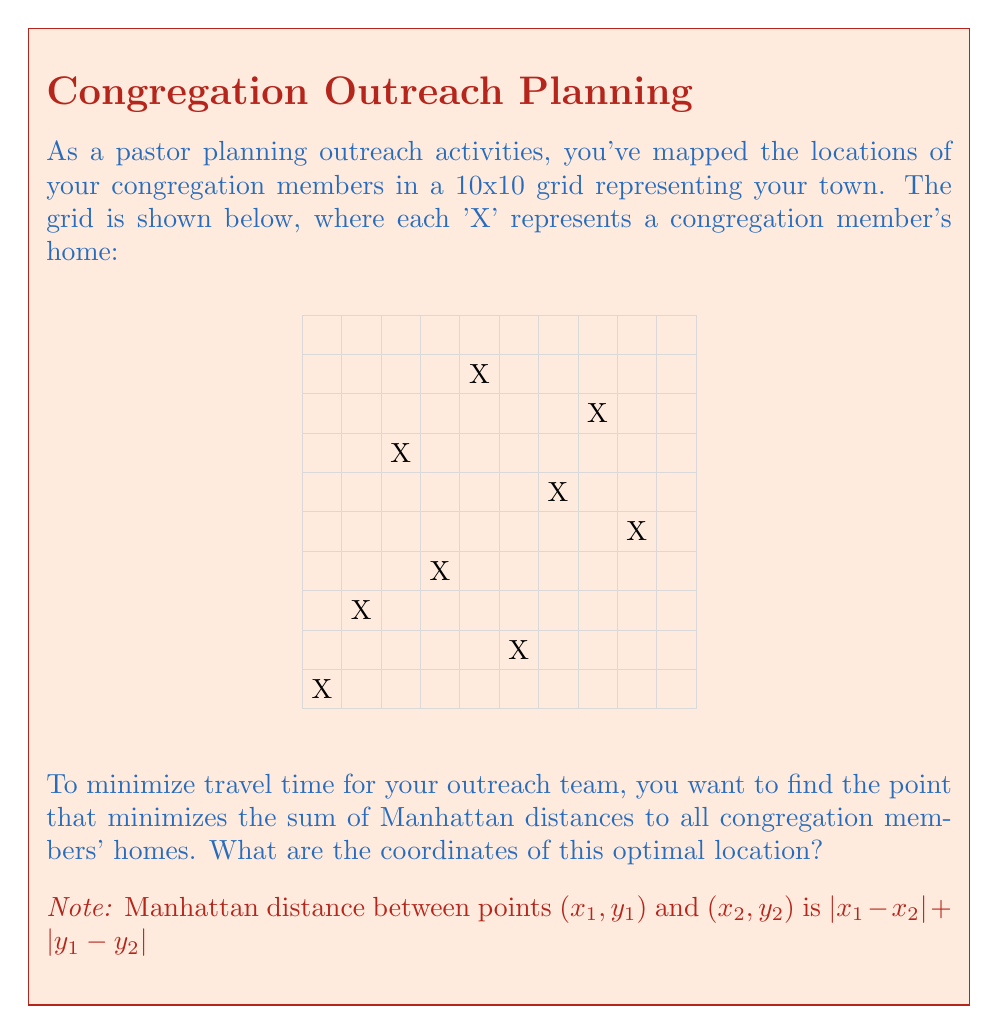Could you help me with this problem? To solve this problem, we need to find the median x-coordinate and median y-coordinate separately. This is because the Manhattan distance can be split into horizontal and vertical components.

Step 1: List all x-coordinates and y-coordinates separately.
x-coordinates: 1, 2, 3, 4, 5, 6, 7, 8, 9
y-coordinates: 1, 3, 7, 4, 9, 2, 6, 8, 5

Step 2: Find the median of x-coordinates.
Sorted x-coordinates: 1, 2, 3, 4, 5, 6, 7, 8, 9
The median x-coordinate is 5 (the 5th number in the sorted list of 9 numbers).

Step 3: Find the median of y-coordinates.
Sorted y-coordinates: 1, 2, 3, 4, 5, 6, 7, 8, 9
The median y-coordinate is 5 (the 5th number in the sorted list of 9 numbers).

Step 4: The optimal point is the intersection of the median x-coordinate and median y-coordinate.

Therefore, the coordinates of the optimal location are (5, 5).

This point minimizes the sum of Manhattan distances because:
1. Any move left or right from x=5 would increase the total distance to the points on the opposite side more than it would decrease the distance to the points on the same side.
2. Similarly, any move up or down from y=5 would increase the total distance more than it would decrease it.

This property holds true for Manhattan distance due to its linear nature in each dimension.
Answer: (5, 5) 